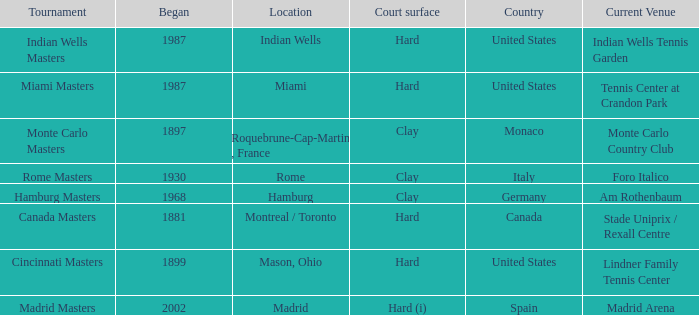Which tournaments current venue is the Madrid Arena? Madrid Masters. Parse the table in full. {'header': ['Tournament', 'Began', 'Location', 'Court surface', 'Country', 'Current Venue'], 'rows': [['Indian Wells Masters', '1987', 'Indian Wells', 'Hard', 'United States', 'Indian Wells Tennis Garden'], ['Miami Masters', '1987', 'Miami', 'Hard', 'United States', 'Tennis Center at Crandon Park'], ['Monte Carlo Masters', '1897', 'Roquebrune-Cap-Martin , France', 'Clay', 'Monaco', 'Monte Carlo Country Club'], ['Rome Masters', '1930', 'Rome', 'Clay', 'Italy', 'Foro Italico'], ['Hamburg Masters', '1968', 'Hamburg', 'Clay', 'Germany', 'Am Rothenbaum'], ['Canada Masters', '1881', 'Montreal / Toronto', 'Hard', 'Canada', 'Stade Uniprix / Rexall Centre'], ['Cincinnati Masters', '1899', 'Mason, Ohio', 'Hard', 'United States', 'Lindner Family Tennis Center'], ['Madrid Masters', '2002', 'Madrid', 'Hard (i)', 'Spain', 'Madrid Arena']]} 